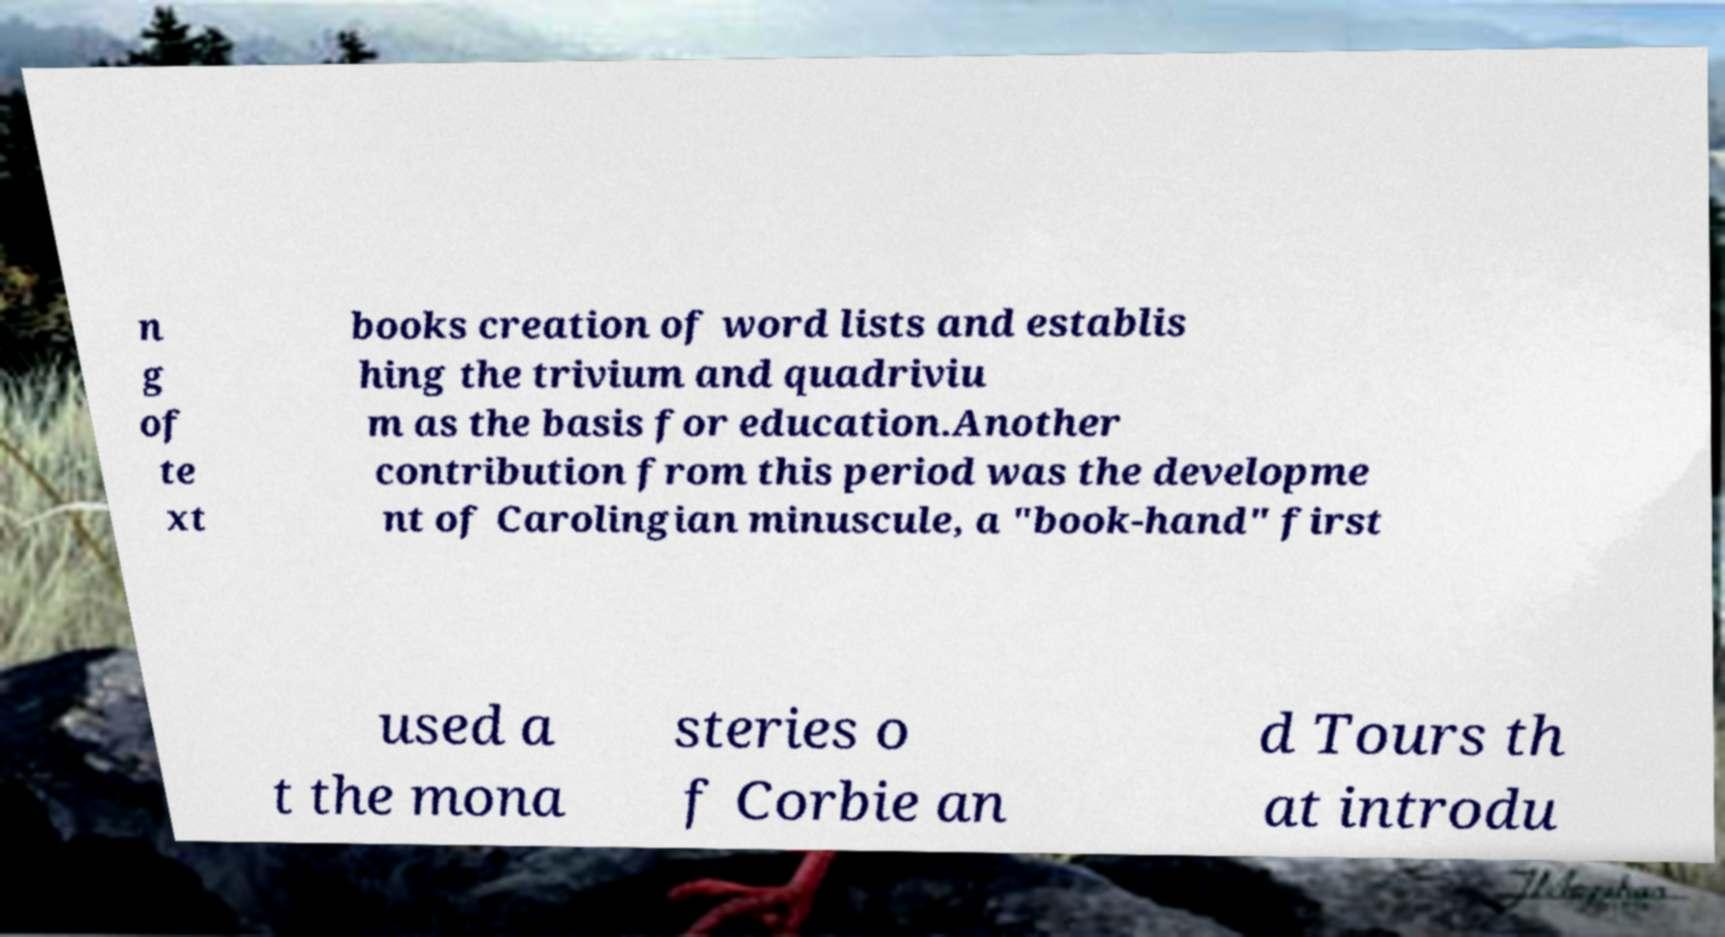There's text embedded in this image that I need extracted. Can you transcribe it verbatim? n g of te xt books creation of word lists and establis hing the trivium and quadriviu m as the basis for education.Another contribution from this period was the developme nt of Carolingian minuscule, a "book-hand" first used a t the mona steries o f Corbie an d Tours th at introdu 